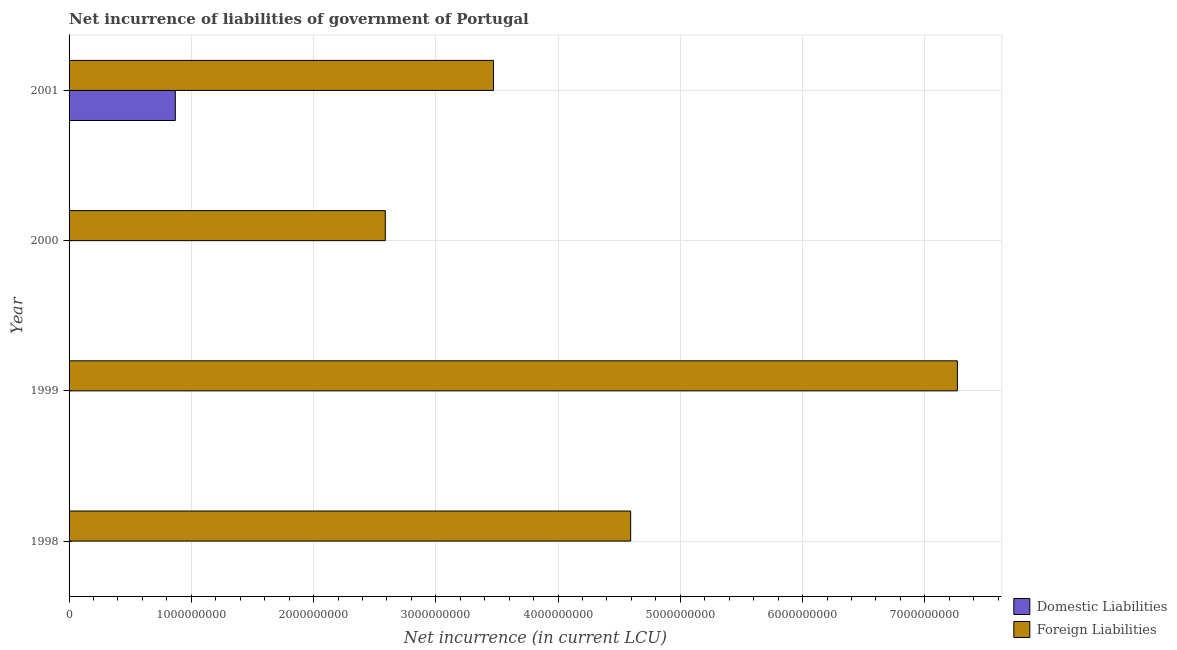How many different coloured bars are there?
Provide a succinct answer. 2. How many bars are there on the 4th tick from the top?
Provide a succinct answer. 1. How many bars are there on the 3rd tick from the bottom?
Offer a terse response. 1. What is the label of the 4th group of bars from the top?
Provide a short and direct response. 1998. In how many cases, is the number of bars for a given year not equal to the number of legend labels?
Offer a very short reply. 3. What is the net incurrence of foreign liabilities in 1998?
Offer a terse response. 4.59e+09. Across all years, what is the maximum net incurrence of foreign liabilities?
Your answer should be very brief. 7.27e+09. Across all years, what is the minimum net incurrence of foreign liabilities?
Ensure brevity in your answer.  2.59e+09. What is the total net incurrence of foreign liabilities in the graph?
Your answer should be very brief. 1.79e+1. What is the difference between the net incurrence of foreign liabilities in 1999 and that in 2000?
Provide a succinct answer. 4.68e+09. What is the difference between the net incurrence of domestic liabilities in 1998 and the net incurrence of foreign liabilities in 2001?
Ensure brevity in your answer.  -3.47e+09. What is the average net incurrence of domestic liabilities per year?
Your answer should be very brief. 2.17e+08. In the year 2001, what is the difference between the net incurrence of domestic liabilities and net incurrence of foreign liabilities?
Offer a terse response. -2.60e+09. In how many years, is the net incurrence of foreign liabilities greater than 5000000000 LCU?
Give a very brief answer. 1. What is the ratio of the net incurrence of foreign liabilities in 1998 to that in 2000?
Offer a very short reply. 1.78. Is the net incurrence of foreign liabilities in 2000 less than that in 2001?
Your response must be concise. Yes. What is the difference between the highest and the second highest net incurrence of foreign liabilities?
Your answer should be very brief. 2.67e+09. What is the difference between the highest and the lowest net incurrence of domestic liabilities?
Provide a short and direct response. 8.69e+08. In how many years, is the net incurrence of domestic liabilities greater than the average net incurrence of domestic liabilities taken over all years?
Make the answer very short. 1. Is the sum of the net incurrence of foreign liabilities in 1998 and 2000 greater than the maximum net incurrence of domestic liabilities across all years?
Ensure brevity in your answer.  Yes. How many bars are there?
Your response must be concise. 5. Are all the bars in the graph horizontal?
Your answer should be very brief. Yes. How many years are there in the graph?
Offer a terse response. 4. Are the values on the major ticks of X-axis written in scientific E-notation?
Offer a very short reply. No. Does the graph contain any zero values?
Ensure brevity in your answer.  Yes. Where does the legend appear in the graph?
Your response must be concise. Bottom right. How many legend labels are there?
Give a very brief answer. 2. What is the title of the graph?
Offer a very short reply. Net incurrence of liabilities of government of Portugal. What is the label or title of the X-axis?
Your answer should be compact. Net incurrence (in current LCU). What is the Net incurrence (in current LCU) in Foreign Liabilities in 1998?
Your response must be concise. 4.59e+09. What is the Net incurrence (in current LCU) of Domestic Liabilities in 1999?
Ensure brevity in your answer.  0. What is the Net incurrence (in current LCU) in Foreign Liabilities in 1999?
Provide a succinct answer. 7.27e+09. What is the Net incurrence (in current LCU) of Foreign Liabilities in 2000?
Give a very brief answer. 2.59e+09. What is the Net incurrence (in current LCU) of Domestic Liabilities in 2001?
Provide a short and direct response. 8.69e+08. What is the Net incurrence (in current LCU) of Foreign Liabilities in 2001?
Your response must be concise. 3.47e+09. Across all years, what is the maximum Net incurrence (in current LCU) in Domestic Liabilities?
Offer a very short reply. 8.69e+08. Across all years, what is the maximum Net incurrence (in current LCU) in Foreign Liabilities?
Ensure brevity in your answer.  7.27e+09. Across all years, what is the minimum Net incurrence (in current LCU) in Foreign Liabilities?
Your answer should be very brief. 2.59e+09. What is the total Net incurrence (in current LCU) of Domestic Liabilities in the graph?
Provide a short and direct response. 8.69e+08. What is the total Net incurrence (in current LCU) in Foreign Liabilities in the graph?
Provide a short and direct response. 1.79e+1. What is the difference between the Net incurrence (in current LCU) of Foreign Liabilities in 1998 and that in 1999?
Your answer should be compact. -2.67e+09. What is the difference between the Net incurrence (in current LCU) in Foreign Liabilities in 1998 and that in 2000?
Give a very brief answer. 2.01e+09. What is the difference between the Net incurrence (in current LCU) of Foreign Liabilities in 1998 and that in 2001?
Make the answer very short. 1.12e+09. What is the difference between the Net incurrence (in current LCU) in Foreign Liabilities in 1999 and that in 2000?
Provide a short and direct response. 4.68e+09. What is the difference between the Net incurrence (in current LCU) in Foreign Liabilities in 1999 and that in 2001?
Provide a short and direct response. 3.80e+09. What is the difference between the Net incurrence (in current LCU) of Foreign Liabilities in 2000 and that in 2001?
Make the answer very short. -8.85e+08. What is the average Net incurrence (in current LCU) of Domestic Liabilities per year?
Your answer should be compact. 2.17e+08. What is the average Net incurrence (in current LCU) of Foreign Liabilities per year?
Offer a terse response. 4.48e+09. In the year 2001, what is the difference between the Net incurrence (in current LCU) in Domestic Liabilities and Net incurrence (in current LCU) in Foreign Liabilities?
Your answer should be compact. -2.60e+09. What is the ratio of the Net incurrence (in current LCU) of Foreign Liabilities in 1998 to that in 1999?
Your response must be concise. 0.63. What is the ratio of the Net incurrence (in current LCU) of Foreign Liabilities in 1998 to that in 2000?
Your answer should be very brief. 1.78. What is the ratio of the Net incurrence (in current LCU) of Foreign Liabilities in 1998 to that in 2001?
Keep it short and to the point. 1.32. What is the ratio of the Net incurrence (in current LCU) of Foreign Liabilities in 1999 to that in 2000?
Ensure brevity in your answer.  2.81. What is the ratio of the Net incurrence (in current LCU) of Foreign Liabilities in 1999 to that in 2001?
Provide a short and direct response. 2.09. What is the ratio of the Net incurrence (in current LCU) of Foreign Liabilities in 2000 to that in 2001?
Provide a succinct answer. 0.75. What is the difference between the highest and the second highest Net incurrence (in current LCU) of Foreign Liabilities?
Keep it short and to the point. 2.67e+09. What is the difference between the highest and the lowest Net incurrence (in current LCU) in Domestic Liabilities?
Keep it short and to the point. 8.69e+08. What is the difference between the highest and the lowest Net incurrence (in current LCU) of Foreign Liabilities?
Your response must be concise. 4.68e+09. 